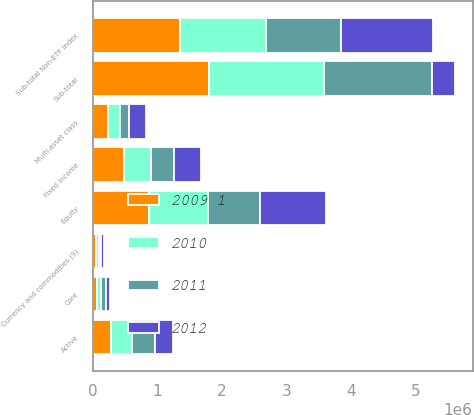Convert chart to OTSL. <chart><loc_0><loc_0><loc_500><loc_500><stacked_bar_chart><ecel><fcel>Active<fcel>Multi-asset class<fcel>Core<fcel>Currency and commodities (9)<fcel>Sub-total<fcel>Equity<fcel>Fixed Income<fcel>Sub-total Non-ETF Index<nl><fcel>2012<fcel>287215<fcel>267748<fcel>68367<fcel>41428<fcel>348574<fcel>1.02364e+06<fcel>410139<fcel>1.43378e+06<nl><fcel>2009 1<fcel>275156<fcel>225170<fcel>63647<fcel>41301<fcel>1.79353e+06<fcel>865299<fcel>479116<fcel>1.34442e+06<nl><fcel>2010<fcel>334532<fcel>185587<fcel>63603<fcel>46135<fcel>1.79341e+06<fcel>911775<fcel>425930<fcel>1.3377e+06<nl><fcel>2011<fcel>348574<fcel>142029<fcel>66058<fcel>36043<fcel>1.67217e+06<fcel>806082<fcel>357557<fcel>1.16364e+06<nl></chart> 